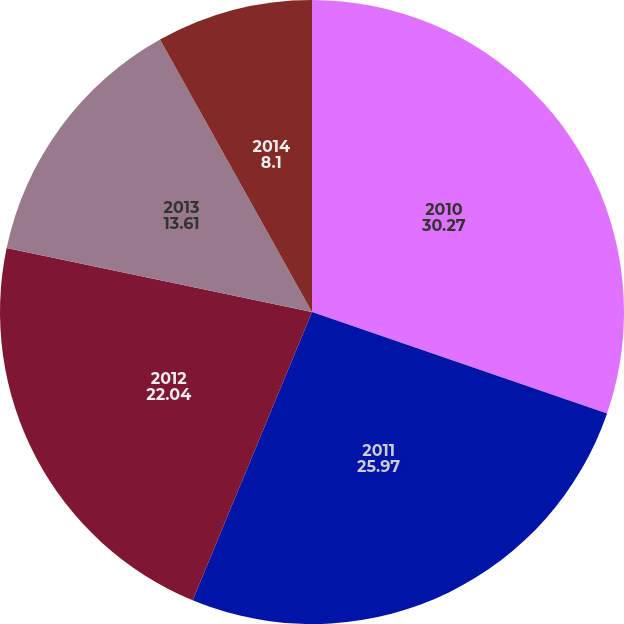<chart> <loc_0><loc_0><loc_500><loc_500><pie_chart><fcel>2010<fcel>2011<fcel>2012<fcel>2013<fcel>2014<nl><fcel>30.27%<fcel>25.97%<fcel>22.04%<fcel>13.61%<fcel>8.1%<nl></chart> 